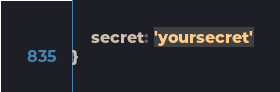<code> <loc_0><loc_0><loc_500><loc_500><_JavaScript_>    secret: 'yoursecret'
}</code> 